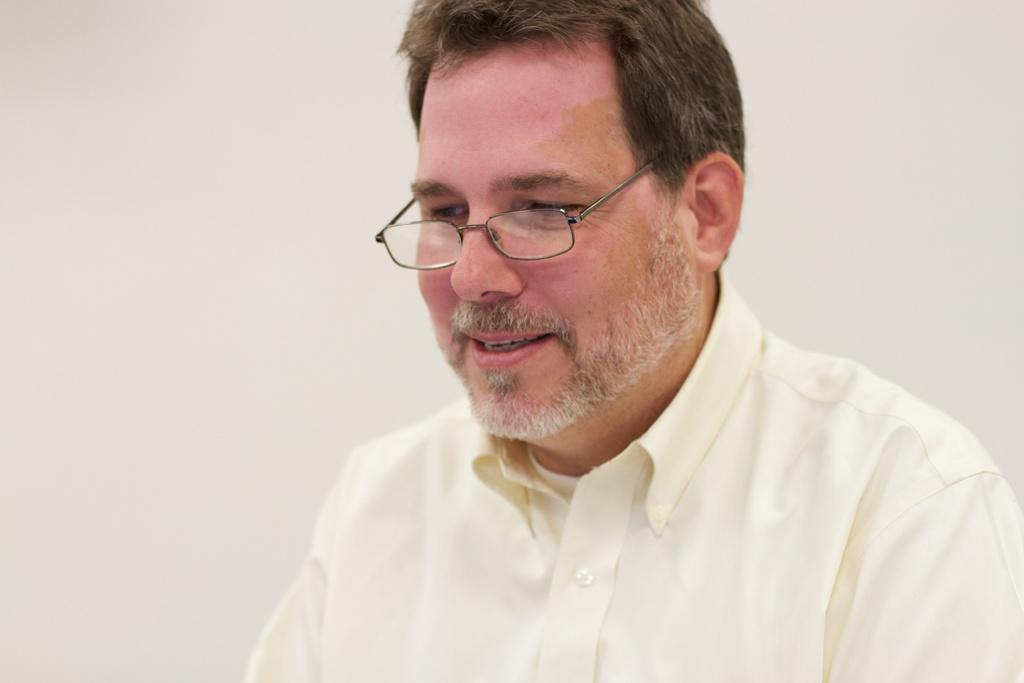How would you summarize this image in a sentence or two? There is a person wearing a shirt and spectacles. There is a white background. 